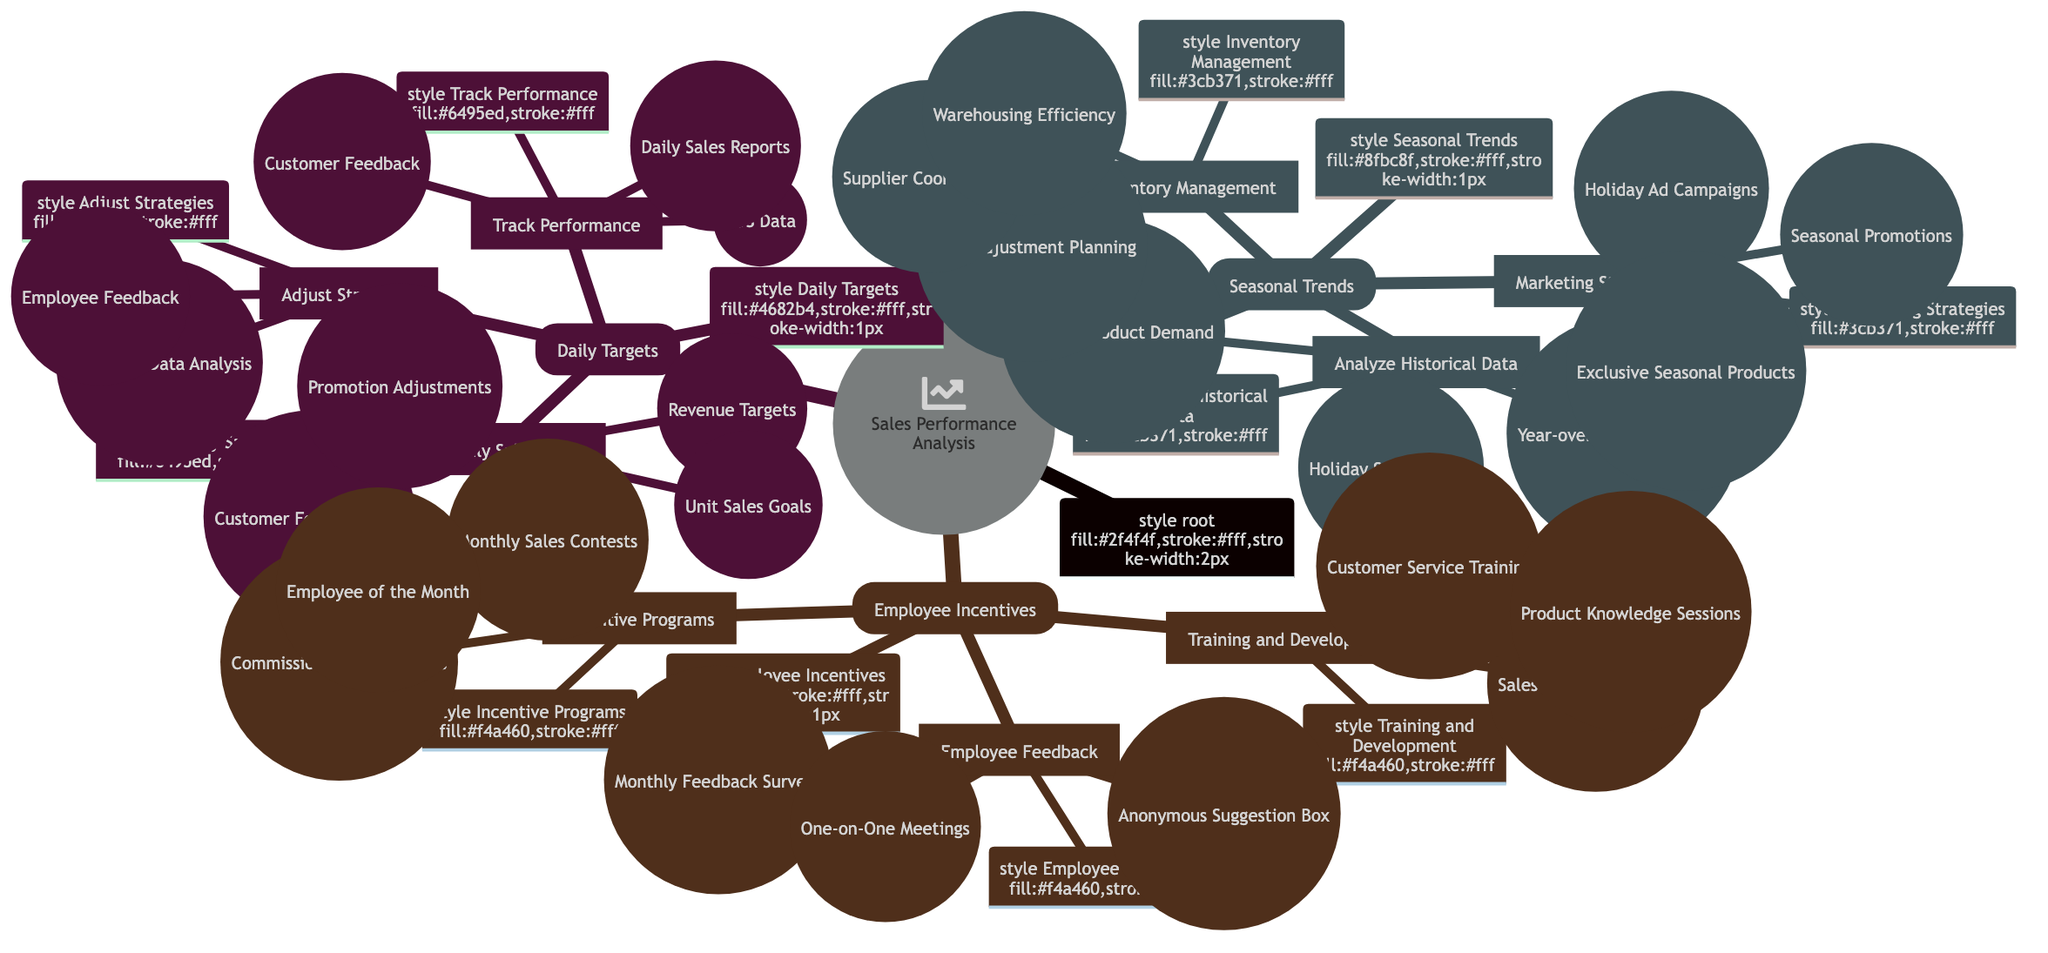What are the main categories of the mind map? The main categories in the mind map are 'Daily Targets,' 'Seasonal Trends,' and 'Employee Incentives.' This can be seen as the top-level nodes branching out from the root of the mind map.
Answer: Daily Targets, Seasonal Trends, Employee Incentives How many goals are set under 'Set Daily Sales Goals'? Under the 'Set Daily Sales Goals' category, there are three specific goals listed: Revenue Targets, Unit Sales Goals, and Customer Footfall Goals. This is identified by counting the sub-nodes beneath that specific category.
Answer: 3 What is one method to track sales performance? One method to track sales performance listed in the mind map is 'Daily Sales Reports.' It's one of the items listed under the 'Track Performance' category.
Answer: Daily Sales Reports Which category focuses on the analysis of sales patterns? The category that focuses on the analysis of sales patterns is 'Seasonal Trends.' This can be determined by looking at the main categories and identifying which one includes the analysis aspect.
Answer: Seasonal Trends What incentive type is highlighted under 'Incentive Programs'? One incentive type highlighted under 'Incentive Programs' is 'Commission-Based Rewards.' This information is indicated in the sub-nodes under the 'Incentive Programs' category.
Answer: Commission-Based Rewards What are two objectives of 'Inventory Management'? Two objectives of 'Inventory Management' are 'Stock Adjustment Planning' and 'Supplier Coordination.' This is found by reviewing the sub-nodes under the 'Inventory Management' category.
Answer: Stock Adjustment Planning, Supplier Coordination How does 'Employee Feedback' contribute to employee incentives? 'Employee Feedback' contributes to employee incentives through mechanisms like 'Monthly Feedback Surveys' and 'One-on-One Meetings,' helping managers understand employee needs and motivation. This is demonstrated by the connections in the diagram relating to Employee Incentives.
Answer: Monthly Feedback Surveys, One-on-One Meetings What is a focus area for 'Training and Development'? A focus area for 'Training and Development' is 'Sales Training Workshops.' This can be observed as a specific training method listed under the Training and Development category.
Answer: Sales Training Workshops How many strategies are listed under 'Marketing Strategies'? There are three strategies listed under 'Marketing Strategies': Seasonal Promotions, Holiday Advertising Campaigns, and Exclusive Seasonal Products. This can be confirmed by counting the sub-nodes under that category.
Answer: 3 